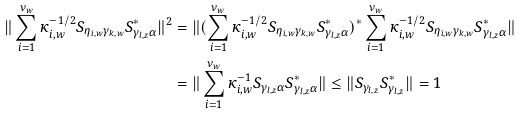<formula> <loc_0><loc_0><loc_500><loc_500>\| \sum _ { i = 1 } ^ { \nu _ { w } } \kappa _ { i , w } ^ { - 1 / 2 } S _ { \eta _ { i , w } \gamma _ { k , w } } S ^ { * } _ { \gamma _ { l , z } \alpha } \| ^ { 2 } & = \| ( \sum _ { i = 1 } ^ { \nu _ { w } } \kappa _ { i , w } ^ { - 1 / 2 } S _ { \eta _ { i , w } \gamma _ { k , w } } S ^ { * } _ { \gamma _ { l , z } \alpha } ) ^ { * } \sum _ { i = 1 } ^ { \nu _ { w } } \kappa _ { i , w } ^ { - 1 / 2 } S _ { \eta _ { i , w } \gamma _ { k , w } } S ^ { * } _ { \gamma _ { l , z } \alpha } \| \\ & = \| \sum _ { i = 1 } ^ { \nu _ { w } } \kappa _ { i , w } ^ { - 1 } S _ { \gamma _ { l , z } \alpha } S ^ { * } _ { \gamma _ { l , z } \alpha } \| \leq \| S _ { \gamma _ { l , z } } S ^ { * } _ { \gamma _ { l , z } } \| = 1</formula> 